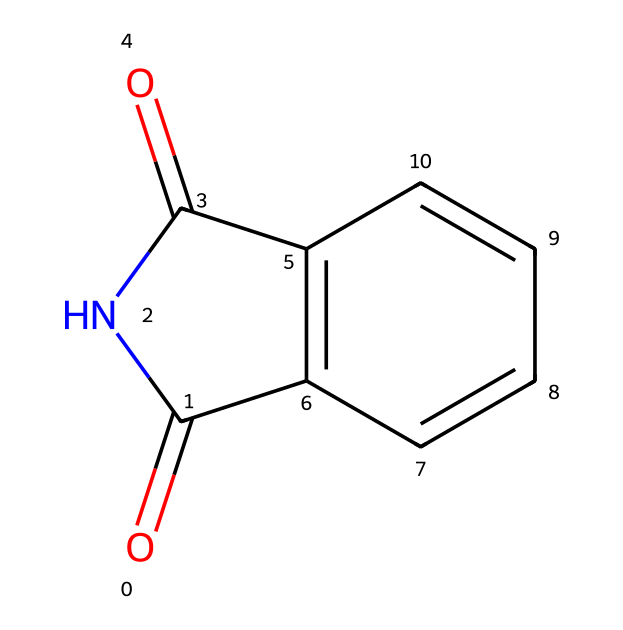What is the name of the chemical structure represented by the SMILES? The SMILES depicts a structure that corresponds to a cyclic imide known as phthalimide due to the arrangement of its atoms and functional groups.
Answer: phthalimide How many nitrogen atoms are present in the chemical structure? By examining the SMILES representation, there is one nitrogen (N) atom located within the imide functional group, indicating its role in forming the ring structure.
Answer: 1 What is the total number of carbon atoms in the structure? The SMILES shows a total of 8 carbon (C) atoms when counting all the carbon elements in the cyclic structure, including those forming the imide and the benzene-like ring.
Answer: 8 What type of chemical functional group is present in this molecule? The presence of the carbonyl (C=O) bonds and nitrogen in a ring defines this molecule as containing an imide functional group, characterized by the connection of carbonyls to nitrogen.
Answer: imide Does this chemical structure contain any aromatic rings? Analyzing the structure, there is a fused benzene-like ring present within the compound, indicating that part of the structure is aromatic due to the alternating double bonds and cyclic nature.
Answer: Yes What is the significance of the imide structure in sports injury pain relievers? The imide structure often leads to the formation of effective pharmaceutical compounds that modulate pain pathways, making it valuable in developing analgesics used for treating sports injuries.
Answer: Analgesics 